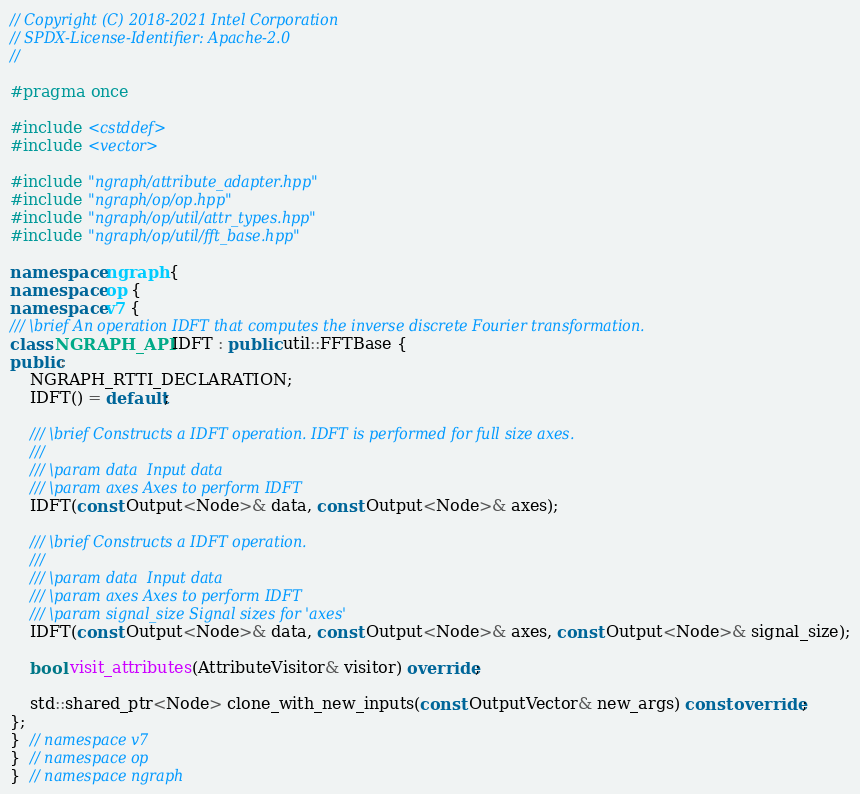Convert code to text. <code><loc_0><loc_0><loc_500><loc_500><_C++_>// Copyright (C) 2018-2021 Intel Corporation
// SPDX-License-Identifier: Apache-2.0
//

#pragma once

#include <cstddef>
#include <vector>

#include "ngraph/attribute_adapter.hpp"
#include "ngraph/op/op.hpp"
#include "ngraph/op/util/attr_types.hpp"
#include "ngraph/op/util/fft_base.hpp"

namespace ngraph {
namespace op {
namespace v7 {
/// \brief An operation IDFT that computes the inverse discrete Fourier transformation.
class NGRAPH_API IDFT : public util::FFTBase {
public:
    NGRAPH_RTTI_DECLARATION;
    IDFT() = default;

    /// \brief Constructs a IDFT operation. IDFT is performed for full size axes.
    ///
    /// \param data  Input data
    /// \param axes Axes to perform IDFT
    IDFT(const Output<Node>& data, const Output<Node>& axes);

    /// \brief Constructs a IDFT operation.
    ///
    /// \param data  Input data
    /// \param axes Axes to perform IDFT
    /// \param signal_size Signal sizes for 'axes'
    IDFT(const Output<Node>& data, const Output<Node>& axes, const Output<Node>& signal_size);

    bool visit_attributes(AttributeVisitor& visitor) override;

    std::shared_ptr<Node> clone_with_new_inputs(const OutputVector& new_args) const override;
};
}  // namespace v7
}  // namespace op
}  // namespace ngraph
</code> 